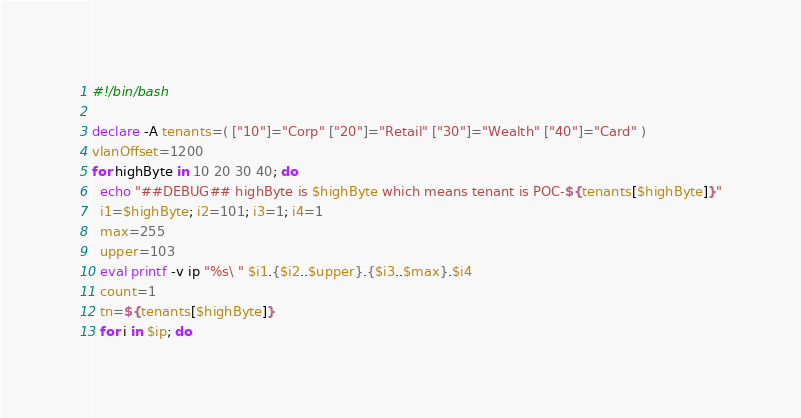Convert code to text. <code><loc_0><loc_0><loc_500><loc_500><_Bash_>#!/bin/bash

declare -A tenants=( ["10"]="Corp" ["20"]="Retail" ["30"]="Wealth" ["40"]="Card" )
vlanOffset=1200
for highByte in 10 20 30 40; do
  echo "##DEBUG## highByte is $highByte which means tenant is POC-${tenants[$highByte]}"
  i1=$highByte; i2=101; i3=1; i4=1
  max=255
  upper=103
  eval printf -v ip "%s\ " $i1.{$i2..$upper}.{$i3..$max}.$i4
  count=1
  tn=${tenants[$highByte]}
  for i in $ip; do</code> 